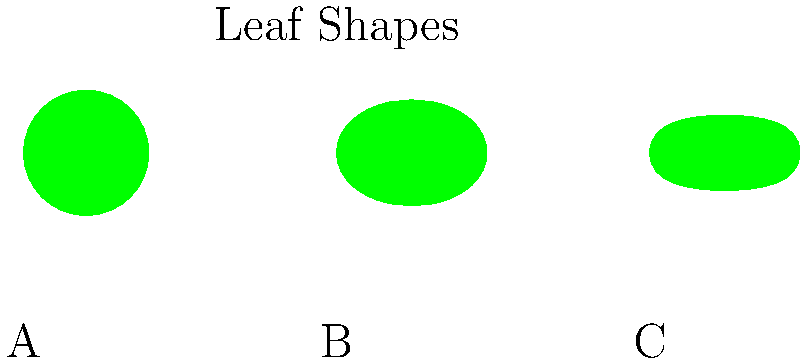In a machine learning project to identify plant species from leaf images, which leaf shape (A, B, or C) is most likely to be classified as an oak leaf? To identify the oak leaf among the given shapes, let's analyze each:

1. Shape A: This leaf has a distinctive lobed shape with rounded edges. It features a symmetrical pattern with typically 5-7 lobes. This is characteristic of oak leaves, particularly those of the white oak family.

2. Shape B: This leaf has a palmate shape with 5 pointed lobes. The central lobe is typically larger than the others. This shape is most commonly associated with maple leaves.

3. Shape C: This leaf has an elliptical or oval shape with serrated edges. It's wider in the middle and tapers at both ends. This shape is typical of elm leaves.

Given these characteristics, Shape A most closely resembles an oak leaf due to its lobed structure and rounded edges.

In a machine learning context, the model would be trained on various leaf shapes and their corresponding species. The features it would likely focus on for oak leaves include:
- The number of lobes (typically 5-7)
- The rounded nature of the lobes
- The overall symmetry of the leaf

Therefore, when presented with these three shapes, a well-trained model would most likely classify Shape A as an oak leaf.
Answer: A 